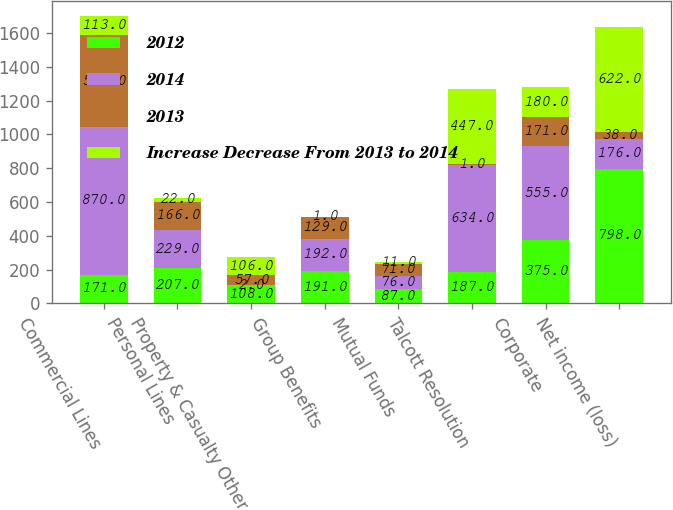Convert chart. <chart><loc_0><loc_0><loc_500><loc_500><stacked_bar_chart><ecel><fcel>Commercial Lines<fcel>Personal Lines<fcel>Property & Casualty Other<fcel>Group Benefits<fcel>Mutual Funds<fcel>Talcott Resolution<fcel>Corporate<fcel>Net income (loss)<nl><fcel>2012<fcel>171<fcel>207<fcel>108<fcel>191<fcel>87<fcel>187<fcel>375<fcel>798<nl><fcel>2014<fcel>870<fcel>229<fcel>2<fcel>192<fcel>76<fcel>634<fcel>555<fcel>176<nl><fcel>2013<fcel>547<fcel>166<fcel>57<fcel>129<fcel>71<fcel>1<fcel>171<fcel>38<nl><fcel>Increase Decrease From 2013 to 2014<fcel>113<fcel>22<fcel>106<fcel>1<fcel>11<fcel>447<fcel>180<fcel>622<nl></chart> 